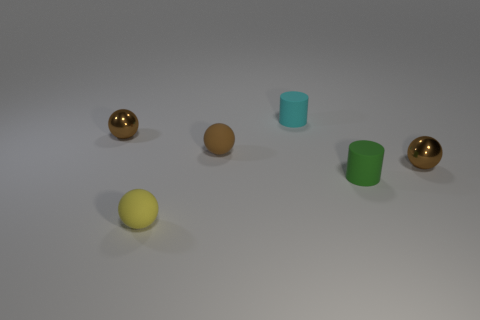Subtract all yellow rubber spheres. How many spheres are left? 3 Add 4 tiny brown metallic things. How many objects exist? 10 Subtract all yellow spheres. How many spheres are left? 3 Subtract 1 cylinders. How many cylinders are left? 1 Subtract all red blocks. How many brown spheres are left? 3 Subtract all cylinders. How many objects are left? 4 Subtract all rubber cylinders. Subtract all small cyan objects. How many objects are left? 3 Add 1 tiny yellow things. How many tiny yellow things are left? 2 Add 5 small balls. How many small balls exist? 9 Subtract 1 cyan cylinders. How many objects are left? 5 